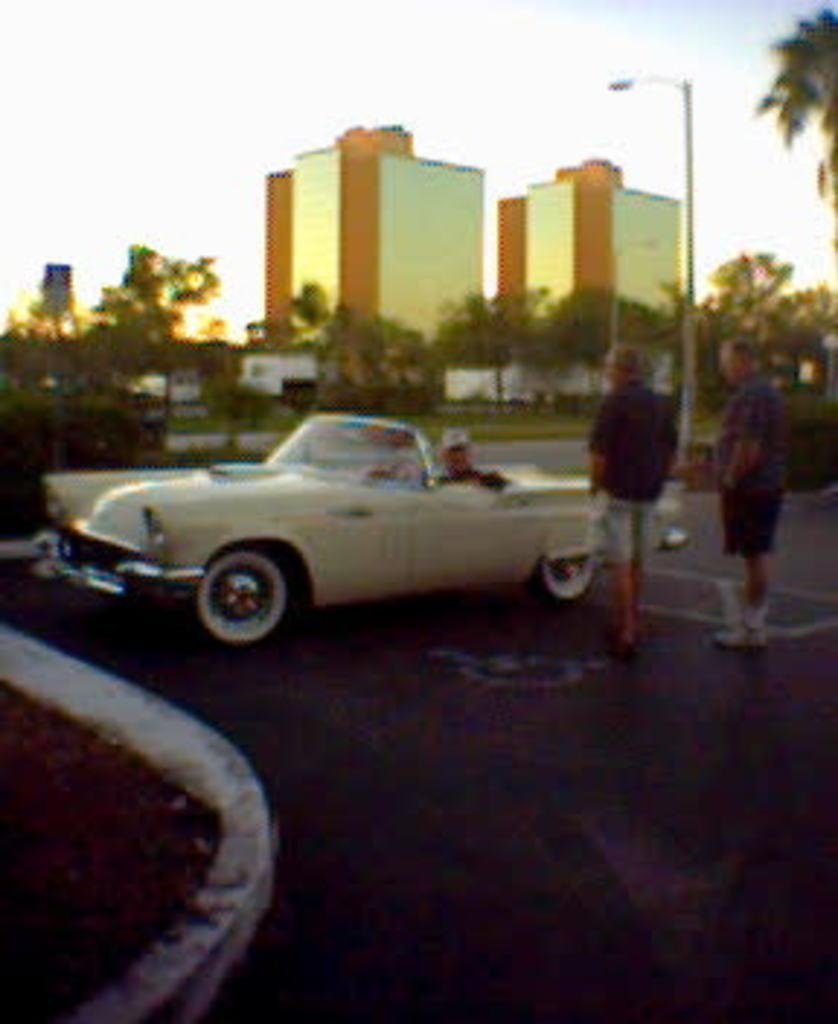What is parked in the image? There is a car parked in the image. How many people are standing in the image? There are two people standing in the image. What structures can be seen in the background of the image? There are buildings visible in the image. What type of vegetation is visible in the image? There are trees visible in the image. What type of button can be seen on the ground in the image? There is no button present on the ground in the image. 